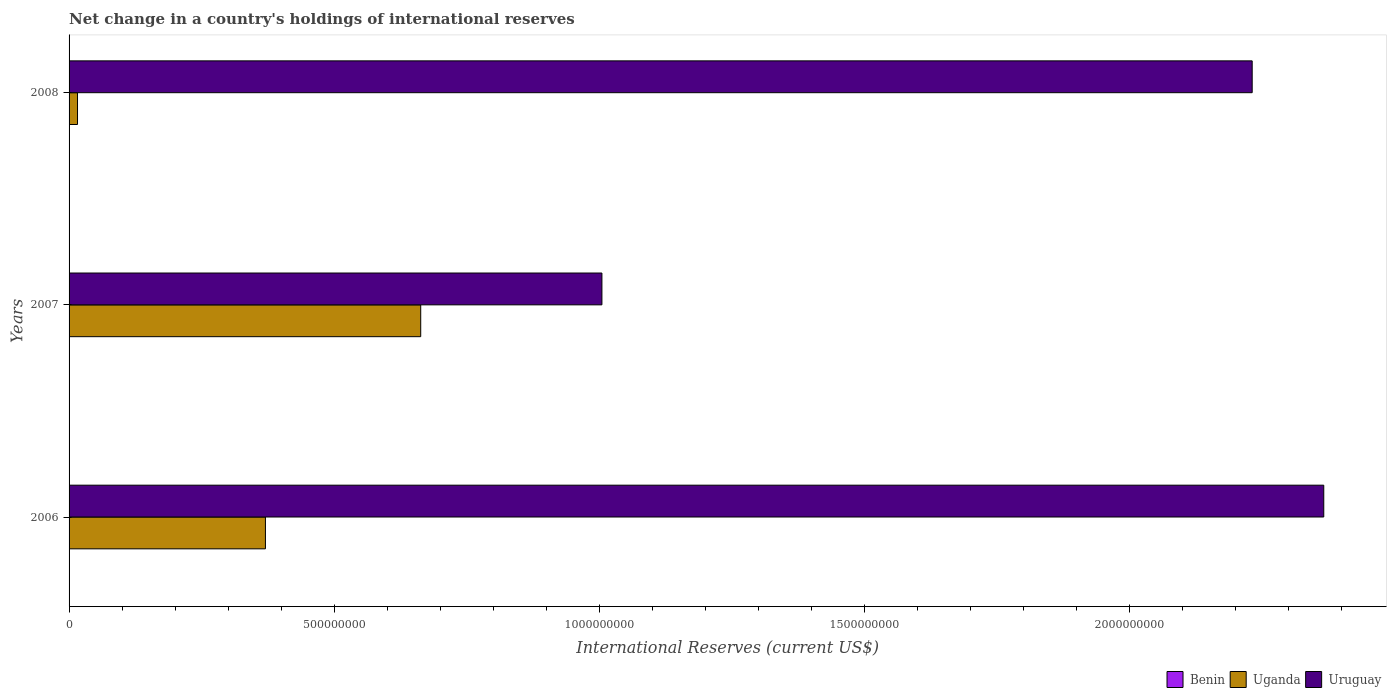What is the international reserves in Benin in 2006?
Provide a succinct answer. 0. Across all years, what is the maximum international reserves in Uruguay?
Keep it short and to the point. 2.37e+09. Across all years, what is the minimum international reserves in Uganda?
Offer a very short reply. 1.59e+07. What is the total international reserves in Uruguay in the graph?
Make the answer very short. 5.61e+09. What is the difference between the international reserves in Uruguay in 2006 and that in 2008?
Offer a terse response. 1.35e+08. What is the difference between the international reserves in Uruguay in 2008 and the international reserves in Uganda in 2007?
Your answer should be compact. 1.57e+09. What is the average international reserves in Uruguay per year?
Your response must be concise. 1.87e+09. In the year 2006, what is the difference between the international reserves in Uganda and international reserves in Uruguay?
Ensure brevity in your answer.  -2.00e+09. What is the ratio of the international reserves in Uganda in 2007 to that in 2008?
Offer a very short reply. 41.68. Is the international reserves in Uruguay in 2006 less than that in 2007?
Ensure brevity in your answer.  No. Is the difference between the international reserves in Uganda in 2006 and 2008 greater than the difference between the international reserves in Uruguay in 2006 and 2008?
Provide a short and direct response. Yes. What is the difference between the highest and the second highest international reserves in Uganda?
Your answer should be very brief. 2.93e+08. What is the difference between the highest and the lowest international reserves in Uruguay?
Your answer should be compact. 1.36e+09. Is it the case that in every year, the sum of the international reserves in Uruguay and international reserves in Uganda is greater than the international reserves in Benin?
Keep it short and to the point. Yes. Are all the bars in the graph horizontal?
Provide a succinct answer. Yes. How many years are there in the graph?
Offer a very short reply. 3. What is the difference between two consecutive major ticks on the X-axis?
Offer a terse response. 5.00e+08. Does the graph contain any zero values?
Your answer should be compact. Yes. Does the graph contain grids?
Your answer should be very brief. No. How many legend labels are there?
Offer a terse response. 3. What is the title of the graph?
Keep it short and to the point. Net change in a country's holdings of international reserves. Does "Isle of Man" appear as one of the legend labels in the graph?
Offer a terse response. No. What is the label or title of the X-axis?
Keep it short and to the point. International Reserves (current US$). What is the label or title of the Y-axis?
Keep it short and to the point. Years. What is the International Reserves (current US$) of Uganda in 2006?
Your response must be concise. 3.70e+08. What is the International Reserves (current US$) in Uruguay in 2006?
Keep it short and to the point. 2.37e+09. What is the International Reserves (current US$) in Benin in 2007?
Keep it short and to the point. 0. What is the International Reserves (current US$) of Uganda in 2007?
Offer a very short reply. 6.64e+08. What is the International Reserves (current US$) in Uruguay in 2007?
Provide a succinct answer. 1.01e+09. What is the International Reserves (current US$) of Benin in 2008?
Offer a terse response. 0. What is the International Reserves (current US$) in Uganda in 2008?
Your response must be concise. 1.59e+07. What is the International Reserves (current US$) in Uruguay in 2008?
Your answer should be very brief. 2.23e+09. Across all years, what is the maximum International Reserves (current US$) in Uganda?
Your answer should be very brief. 6.64e+08. Across all years, what is the maximum International Reserves (current US$) of Uruguay?
Make the answer very short. 2.37e+09. Across all years, what is the minimum International Reserves (current US$) of Uganda?
Your response must be concise. 1.59e+07. Across all years, what is the minimum International Reserves (current US$) in Uruguay?
Ensure brevity in your answer.  1.01e+09. What is the total International Reserves (current US$) of Benin in the graph?
Offer a very short reply. 0. What is the total International Reserves (current US$) in Uganda in the graph?
Your response must be concise. 1.05e+09. What is the total International Reserves (current US$) in Uruguay in the graph?
Ensure brevity in your answer.  5.61e+09. What is the difference between the International Reserves (current US$) in Uganda in 2006 and that in 2007?
Your answer should be compact. -2.93e+08. What is the difference between the International Reserves (current US$) in Uruguay in 2006 and that in 2007?
Give a very brief answer. 1.36e+09. What is the difference between the International Reserves (current US$) in Uganda in 2006 and that in 2008?
Give a very brief answer. 3.55e+08. What is the difference between the International Reserves (current US$) in Uruguay in 2006 and that in 2008?
Provide a succinct answer. 1.35e+08. What is the difference between the International Reserves (current US$) in Uganda in 2007 and that in 2008?
Your answer should be compact. 6.48e+08. What is the difference between the International Reserves (current US$) in Uruguay in 2007 and that in 2008?
Your answer should be very brief. -1.23e+09. What is the difference between the International Reserves (current US$) in Uganda in 2006 and the International Reserves (current US$) in Uruguay in 2007?
Your response must be concise. -6.35e+08. What is the difference between the International Reserves (current US$) of Uganda in 2006 and the International Reserves (current US$) of Uruguay in 2008?
Give a very brief answer. -1.86e+09. What is the difference between the International Reserves (current US$) in Uganda in 2007 and the International Reserves (current US$) in Uruguay in 2008?
Offer a terse response. -1.57e+09. What is the average International Reserves (current US$) in Uganda per year?
Your answer should be compact. 3.50e+08. What is the average International Reserves (current US$) of Uruguay per year?
Make the answer very short. 1.87e+09. In the year 2006, what is the difference between the International Reserves (current US$) in Uganda and International Reserves (current US$) in Uruguay?
Your response must be concise. -2.00e+09. In the year 2007, what is the difference between the International Reserves (current US$) of Uganda and International Reserves (current US$) of Uruguay?
Your answer should be compact. -3.42e+08. In the year 2008, what is the difference between the International Reserves (current US$) of Uganda and International Reserves (current US$) of Uruguay?
Provide a succinct answer. -2.22e+09. What is the ratio of the International Reserves (current US$) in Uganda in 2006 to that in 2007?
Provide a short and direct response. 0.56. What is the ratio of the International Reserves (current US$) of Uruguay in 2006 to that in 2007?
Your response must be concise. 2.35. What is the ratio of the International Reserves (current US$) in Uganda in 2006 to that in 2008?
Keep it short and to the point. 23.27. What is the ratio of the International Reserves (current US$) in Uruguay in 2006 to that in 2008?
Offer a terse response. 1.06. What is the ratio of the International Reserves (current US$) in Uganda in 2007 to that in 2008?
Offer a very short reply. 41.68. What is the ratio of the International Reserves (current US$) in Uruguay in 2007 to that in 2008?
Ensure brevity in your answer.  0.45. What is the difference between the highest and the second highest International Reserves (current US$) in Uganda?
Your answer should be compact. 2.93e+08. What is the difference between the highest and the second highest International Reserves (current US$) of Uruguay?
Your answer should be very brief. 1.35e+08. What is the difference between the highest and the lowest International Reserves (current US$) of Uganda?
Your answer should be compact. 6.48e+08. What is the difference between the highest and the lowest International Reserves (current US$) in Uruguay?
Give a very brief answer. 1.36e+09. 